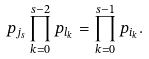<formula> <loc_0><loc_0><loc_500><loc_500>p _ { j _ { s } } \prod _ { k = 0 } ^ { s - 2 } p _ { l _ { k } } = \prod _ { k = 0 } ^ { s - 1 } p _ { i _ { k } } .</formula> 